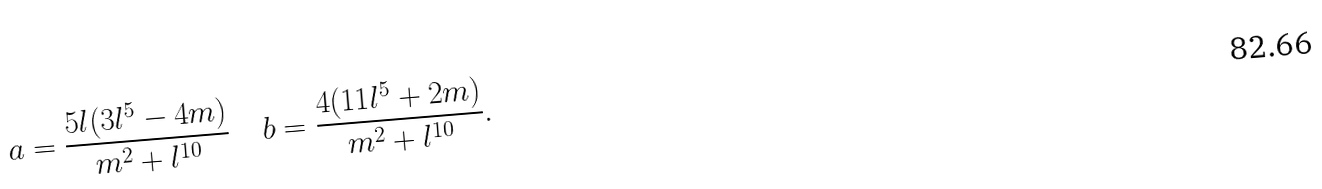<formula> <loc_0><loc_0><loc_500><loc_500>a = { \frac { 5 l ( 3 l ^ { 5 } - 4 m ) } { m ^ { 2 } + l ^ { 1 0 } } } \quad b = { \frac { 4 ( 1 1 l ^ { 5 } + 2 m ) } { m ^ { 2 } + l ^ { 1 0 } } } .</formula> 